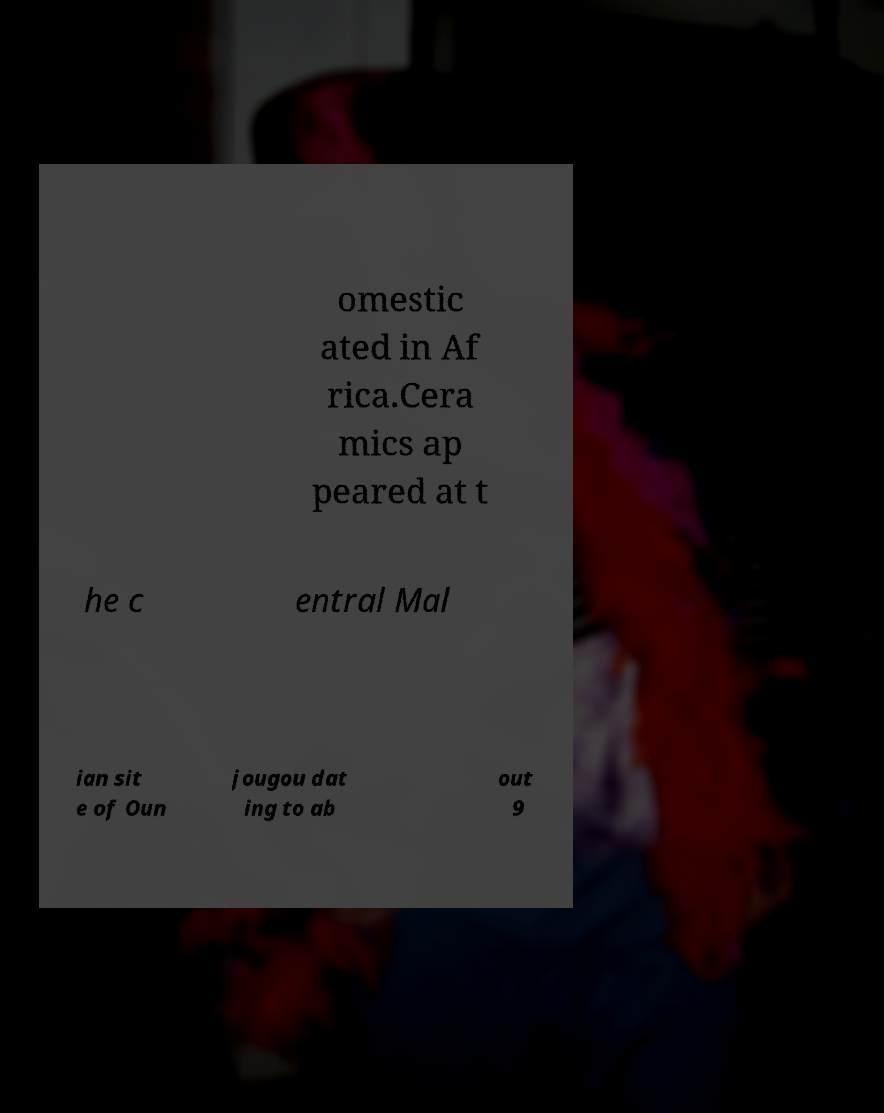Please identify and transcribe the text found in this image. omestic ated in Af rica.Cera mics ap peared at t he c entral Mal ian sit e of Oun jougou dat ing to ab out 9 